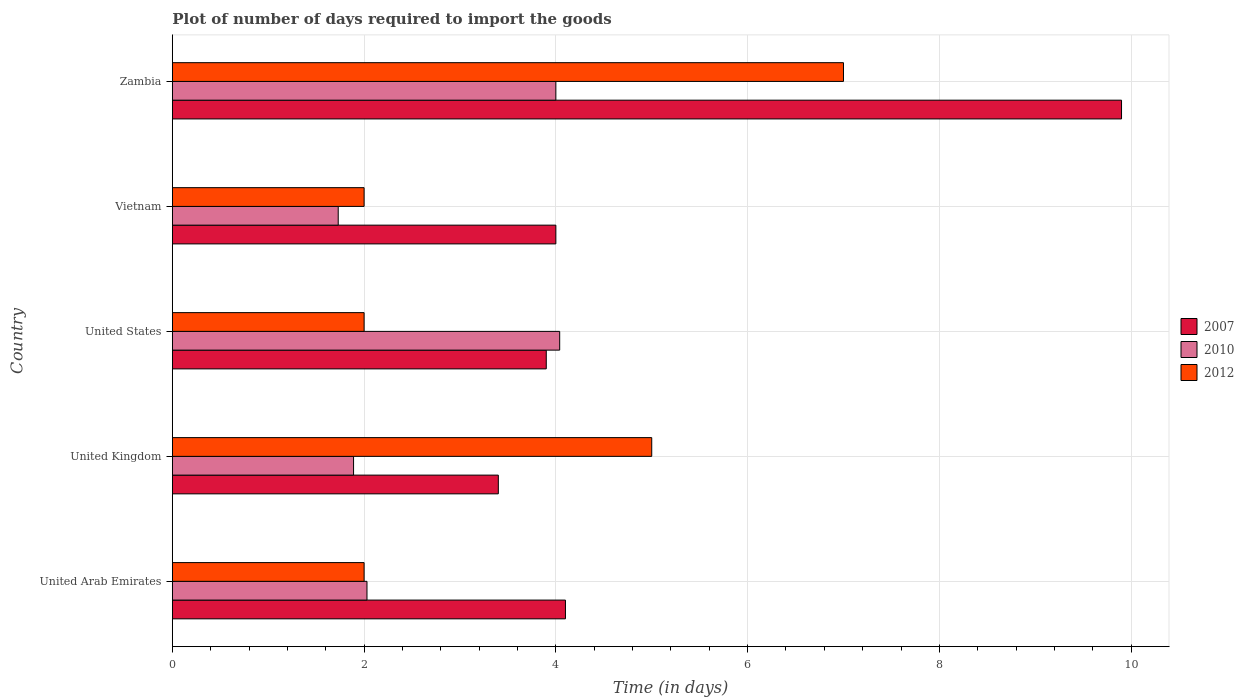How many different coloured bars are there?
Ensure brevity in your answer.  3. How many groups of bars are there?
Your answer should be very brief. 5. Are the number of bars per tick equal to the number of legend labels?
Keep it short and to the point. Yes. How many bars are there on the 3rd tick from the top?
Give a very brief answer. 3. How many bars are there on the 2nd tick from the bottom?
Give a very brief answer. 3. What is the label of the 1st group of bars from the top?
Offer a very short reply. Zambia. Across all countries, what is the minimum time required to import goods in 2012?
Offer a very short reply. 2. In which country was the time required to import goods in 2012 maximum?
Your response must be concise. Zambia. What is the difference between the time required to import goods in 2010 in United Arab Emirates and that in Vietnam?
Your answer should be very brief. 0.3. What is the difference between the time required to import goods in 2012 in United Kingdom and the time required to import goods in 2010 in Vietnam?
Keep it short and to the point. 3.27. What is the average time required to import goods in 2007 per country?
Ensure brevity in your answer.  5.06. What is the difference between the time required to import goods in 2012 and time required to import goods in 2010 in United Kingdom?
Provide a succinct answer. 3.11. What is the ratio of the time required to import goods in 2012 in United Arab Emirates to that in Zambia?
Provide a succinct answer. 0.29. Is the difference between the time required to import goods in 2012 in United States and Zambia greater than the difference between the time required to import goods in 2010 in United States and Zambia?
Provide a short and direct response. No. What is the difference between the highest and the second highest time required to import goods in 2007?
Provide a succinct answer. 5.8. What is the difference between the highest and the lowest time required to import goods in 2010?
Keep it short and to the point. 2.31. What does the 1st bar from the top in United Arab Emirates represents?
Provide a short and direct response. 2012. What does the 3rd bar from the bottom in United States represents?
Offer a terse response. 2012. How many bars are there?
Your answer should be compact. 15. What is the difference between two consecutive major ticks on the X-axis?
Ensure brevity in your answer.  2. Are the values on the major ticks of X-axis written in scientific E-notation?
Offer a terse response. No. Does the graph contain grids?
Your answer should be very brief. Yes. Where does the legend appear in the graph?
Your answer should be very brief. Center right. What is the title of the graph?
Keep it short and to the point. Plot of number of days required to import the goods. Does "1973" appear as one of the legend labels in the graph?
Offer a terse response. No. What is the label or title of the X-axis?
Provide a succinct answer. Time (in days). What is the Time (in days) of 2010 in United Arab Emirates?
Ensure brevity in your answer.  2.03. What is the Time (in days) of 2012 in United Arab Emirates?
Your response must be concise. 2. What is the Time (in days) in 2007 in United Kingdom?
Ensure brevity in your answer.  3.4. What is the Time (in days) in 2010 in United Kingdom?
Your answer should be very brief. 1.89. What is the Time (in days) in 2012 in United Kingdom?
Your answer should be compact. 5. What is the Time (in days) in 2010 in United States?
Offer a terse response. 4.04. What is the Time (in days) in 2010 in Vietnam?
Keep it short and to the point. 1.73. What is the Time (in days) of 2007 in Zambia?
Make the answer very short. 9.9. What is the Time (in days) in 2012 in Zambia?
Provide a succinct answer. 7. Across all countries, what is the maximum Time (in days) in 2007?
Provide a succinct answer. 9.9. Across all countries, what is the maximum Time (in days) of 2010?
Your answer should be compact. 4.04. Across all countries, what is the maximum Time (in days) of 2012?
Offer a very short reply. 7. Across all countries, what is the minimum Time (in days) of 2007?
Give a very brief answer. 3.4. Across all countries, what is the minimum Time (in days) in 2010?
Your answer should be compact. 1.73. Across all countries, what is the minimum Time (in days) of 2012?
Offer a terse response. 2. What is the total Time (in days) in 2007 in the graph?
Your response must be concise. 25.3. What is the total Time (in days) of 2010 in the graph?
Offer a terse response. 13.69. What is the total Time (in days) of 2012 in the graph?
Make the answer very short. 18. What is the difference between the Time (in days) of 2007 in United Arab Emirates and that in United Kingdom?
Ensure brevity in your answer.  0.7. What is the difference between the Time (in days) in 2010 in United Arab Emirates and that in United Kingdom?
Ensure brevity in your answer.  0.14. What is the difference between the Time (in days) in 2010 in United Arab Emirates and that in United States?
Provide a short and direct response. -2.01. What is the difference between the Time (in days) in 2012 in United Arab Emirates and that in United States?
Your response must be concise. 0. What is the difference between the Time (in days) of 2010 in United Arab Emirates and that in Vietnam?
Offer a terse response. 0.3. What is the difference between the Time (in days) in 2012 in United Arab Emirates and that in Vietnam?
Keep it short and to the point. 0. What is the difference between the Time (in days) of 2007 in United Arab Emirates and that in Zambia?
Ensure brevity in your answer.  -5.8. What is the difference between the Time (in days) in 2010 in United Arab Emirates and that in Zambia?
Your answer should be very brief. -1.97. What is the difference between the Time (in days) in 2007 in United Kingdom and that in United States?
Make the answer very short. -0.5. What is the difference between the Time (in days) of 2010 in United Kingdom and that in United States?
Offer a terse response. -2.15. What is the difference between the Time (in days) of 2012 in United Kingdom and that in United States?
Keep it short and to the point. 3. What is the difference between the Time (in days) of 2007 in United Kingdom and that in Vietnam?
Keep it short and to the point. -0.6. What is the difference between the Time (in days) in 2010 in United Kingdom and that in Vietnam?
Provide a short and direct response. 0.16. What is the difference between the Time (in days) of 2012 in United Kingdom and that in Vietnam?
Your answer should be very brief. 3. What is the difference between the Time (in days) of 2007 in United Kingdom and that in Zambia?
Ensure brevity in your answer.  -6.5. What is the difference between the Time (in days) in 2010 in United Kingdom and that in Zambia?
Keep it short and to the point. -2.11. What is the difference between the Time (in days) in 2007 in United States and that in Vietnam?
Your answer should be compact. -0.1. What is the difference between the Time (in days) of 2010 in United States and that in Vietnam?
Ensure brevity in your answer.  2.31. What is the difference between the Time (in days) in 2012 in United States and that in Vietnam?
Offer a very short reply. 0. What is the difference between the Time (in days) in 2010 in United States and that in Zambia?
Keep it short and to the point. 0.04. What is the difference between the Time (in days) of 2012 in United States and that in Zambia?
Your answer should be compact. -5. What is the difference between the Time (in days) of 2007 in Vietnam and that in Zambia?
Keep it short and to the point. -5.9. What is the difference between the Time (in days) of 2010 in Vietnam and that in Zambia?
Your response must be concise. -2.27. What is the difference between the Time (in days) of 2012 in Vietnam and that in Zambia?
Make the answer very short. -5. What is the difference between the Time (in days) of 2007 in United Arab Emirates and the Time (in days) of 2010 in United Kingdom?
Your answer should be very brief. 2.21. What is the difference between the Time (in days) in 2010 in United Arab Emirates and the Time (in days) in 2012 in United Kingdom?
Provide a succinct answer. -2.97. What is the difference between the Time (in days) in 2010 in United Arab Emirates and the Time (in days) in 2012 in United States?
Offer a terse response. 0.03. What is the difference between the Time (in days) of 2007 in United Arab Emirates and the Time (in days) of 2010 in Vietnam?
Make the answer very short. 2.37. What is the difference between the Time (in days) of 2010 in United Arab Emirates and the Time (in days) of 2012 in Zambia?
Ensure brevity in your answer.  -4.97. What is the difference between the Time (in days) of 2007 in United Kingdom and the Time (in days) of 2010 in United States?
Offer a terse response. -0.64. What is the difference between the Time (in days) of 2007 in United Kingdom and the Time (in days) of 2012 in United States?
Offer a terse response. 1.4. What is the difference between the Time (in days) in 2010 in United Kingdom and the Time (in days) in 2012 in United States?
Give a very brief answer. -0.11. What is the difference between the Time (in days) in 2007 in United Kingdom and the Time (in days) in 2010 in Vietnam?
Your answer should be very brief. 1.67. What is the difference between the Time (in days) of 2010 in United Kingdom and the Time (in days) of 2012 in Vietnam?
Keep it short and to the point. -0.11. What is the difference between the Time (in days) of 2010 in United Kingdom and the Time (in days) of 2012 in Zambia?
Provide a succinct answer. -5.11. What is the difference between the Time (in days) in 2007 in United States and the Time (in days) in 2010 in Vietnam?
Provide a short and direct response. 2.17. What is the difference between the Time (in days) of 2010 in United States and the Time (in days) of 2012 in Vietnam?
Make the answer very short. 2.04. What is the difference between the Time (in days) of 2007 in United States and the Time (in days) of 2010 in Zambia?
Provide a succinct answer. -0.1. What is the difference between the Time (in days) of 2010 in United States and the Time (in days) of 2012 in Zambia?
Provide a succinct answer. -2.96. What is the difference between the Time (in days) in 2007 in Vietnam and the Time (in days) in 2010 in Zambia?
Your answer should be very brief. 0. What is the difference between the Time (in days) in 2007 in Vietnam and the Time (in days) in 2012 in Zambia?
Your answer should be compact. -3. What is the difference between the Time (in days) of 2010 in Vietnam and the Time (in days) of 2012 in Zambia?
Your response must be concise. -5.27. What is the average Time (in days) of 2007 per country?
Give a very brief answer. 5.06. What is the average Time (in days) of 2010 per country?
Keep it short and to the point. 2.74. What is the average Time (in days) in 2012 per country?
Ensure brevity in your answer.  3.6. What is the difference between the Time (in days) in 2007 and Time (in days) in 2010 in United Arab Emirates?
Make the answer very short. 2.07. What is the difference between the Time (in days) in 2007 and Time (in days) in 2010 in United Kingdom?
Your response must be concise. 1.51. What is the difference between the Time (in days) of 2007 and Time (in days) of 2012 in United Kingdom?
Provide a short and direct response. -1.6. What is the difference between the Time (in days) in 2010 and Time (in days) in 2012 in United Kingdom?
Give a very brief answer. -3.11. What is the difference between the Time (in days) in 2007 and Time (in days) in 2010 in United States?
Your response must be concise. -0.14. What is the difference between the Time (in days) in 2010 and Time (in days) in 2012 in United States?
Provide a short and direct response. 2.04. What is the difference between the Time (in days) of 2007 and Time (in days) of 2010 in Vietnam?
Offer a terse response. 2.27. What is the difference between the Time (in days) in 2007 and Time (in days) in 2012 in Vietnam?
Your answer should be very brief. 2. What is the difference between the Time (in days) of 2010 and Time (in days) of 2012 in Vietnam?
Offer a terse response. -0.27. What is the difference between the Time (in days) in 2007 and Time (in days) in 2010 in Zambia?
Keep it short and to the point. 5.9. What is the difference between the Time (in days) in 2010 and Time (in days) in 2012 in Zambia?
Keep it short and to the point. -3. What is the ratio of the Time (in days) of 2007 in United Arab Emirates to that in United Kingdom?
Provide a succinct answer. 1.21. What is the ratio of the Time (in days) of 2010 in United Arab Emirates to that in United Kingdom?
Provide a short and direct response. 1.07. What is the ratio of the Time (in days) in 2012 in United Arab Emirates to that in United Kingdom?
Ensure brevity in your answer.  0.4. What is the ratio of the Time (in days) of 2007 in United Arab Emirates to that in United States?
Offer a terse response. 1.05. What is the ratio of the Time (in days) of 2010 in United Arab Emirates to that in United States?
Make the answer very short. 0.5. What is the ratio of the Time (in days) of 2012 in United Arab Emirates to that in United States?
Keep it short and to the point. 1. What is the ratio of the Time (in days) in 2010 in United Arab Emirates to that in Vietnam?
Your answer should be very brief. 1.17. What is the ratio of the Time (in days) in 2007 in United Arab Emirates to that in Zambia?
Ensure brevity in your answer.  0.41. What is the ratio of the Time (in days) in 2010 in United Arab Emirates to that in Zambia?
Ensure brevity in your answer.  0.51. What is the ratio of the Time (in days) of 2012 in United Arab Emirates to that in Zambia?
Ensure brevity in your answer.  0.29. What is the ratio of the Time (in days) of 2007 in United Kingdom to that in United States?
Keep it short and to the point. 0.87. What is the ratio of the Time (in days) in 2010 in United Kingdom to that in United States?
Offer a terse response. 0.47. What is the ratio of the Time (in days) in 2012 in United Kingdom to that in United States?
Provide a succinct answer. 2.5. What is the ratio of the Time (in days) in 2010 in United Kingdom to that in Vietnam?
Your answer should be very brief. 1.09. What is the ratio of the Time (in days) of 2012 in United Kingdom to that in Vietnam?
Your answer should be very brief. 2.5. What is the ratio of the Time (in days) in 2007 in United Kingdom to that in Zambia?
Offer a very short reply. 0.34. What is the ratio of the Time (in days) of 2010 in United Kingdom to that in Zambia?
Your answer should be very brief. 0.47. What is the ratio of the Time (in days) in 2010 in United States to that in Vietnam?
Provide a short and direct response. 2.34. What is the ratio of the Time (in days) of 2012 in United States to that in Vietnam?
Give a very brief answer. 1. What is the ratio of the Time (in days) of 2007 in United States to that in Zambia?
Keep it short and to the point. 0.39. What is the ratio of the Time (in days) of 2010 in United States to that in Zambia?
Your answer should be very brief. 1.01. What is the ratio of the Time (in days) in 2012 in United States to that in Zambia?
Give a very brief answer. 0.29. What is the ratio of the Time (in days) in 2007 in Vietnam to that in Zambia?
Your answer should be very brief. 0.4. What is the ratio of the Time (in days) in 2010 in Vietnam to that in Zambia?
Offer a terse response. 0.43. What is the ratio of the Time (in days) of 2012 in Vietnam to that in Zambia?
Offer a terse response. 0.29. What is the difference between the highest and the second highest Time (in days) of 2010?
Your answer should be very brief. 0.04. What is the difference between the highest and the lowest Time (in days) in 2010?
Keep it short and to the point. 2.31. What is the difference between the highest and the lowest Time (in days) of 2012?
Offer a terse response. 5. 